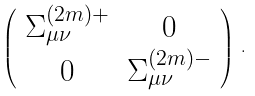Convert formula to latex. <formula><loc_0><loc_0><loc_500><loc_500>\left ( \begin{array} { c c } \Sigma _ { \mu \nu } ^ { ( 2 m ) + } & 0 \\ 0 & \Sigma _ { \mu \nu } ^ { ( 2 m ) - } \end{array} \right ) \, .</formula> 